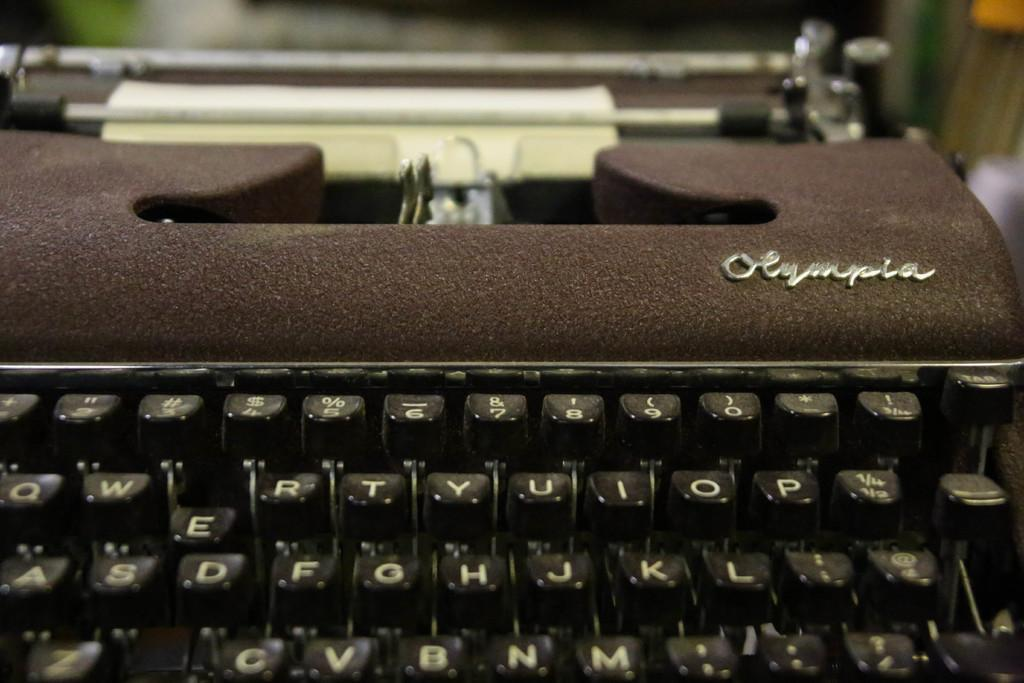Provide a one-sentence caption for the provided image. An old fashion black typewriter from Olympia with square keys that also has a piece of paper in it. 